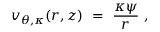Convert formula to latex. <formula><loc_0><loc_0><loc_500><loc_500>v _ { \theta , \kappa } ( r , z ) \ = \ \frac { \kappa \psi } { r } ,</formula> 